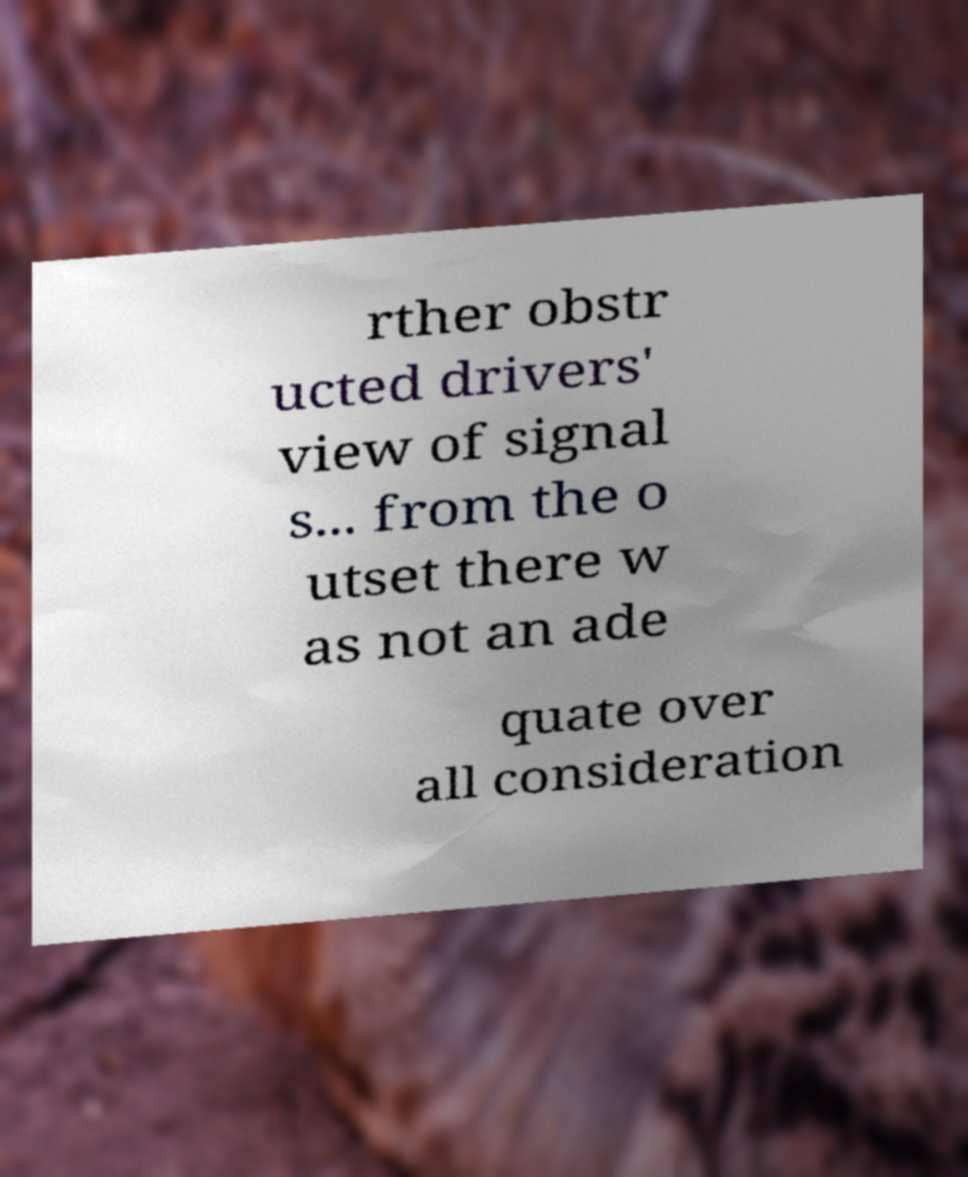Can you read and provide the text displayed in the image?This photo seems to have some interesting text. Can you extract and type it out for me? rther obstr ucted drivers' view of signal s... from the o utset there w as not an ade quate over all consideration 